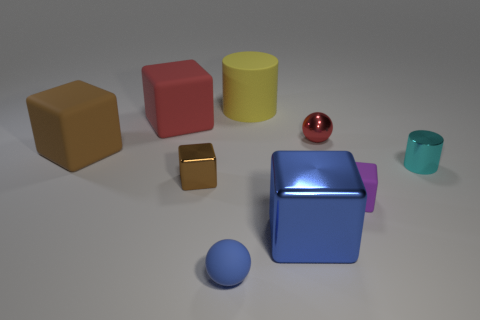Subtract 2 cubes. How many cubes are left? 3 Subtract all purple blocks. How many blocks are left? 4 Subtract all blue blocks. How many blocks are left? 4 Subtract all yellow blocks. Subtract all cyan spheres. How many blocks are left? 5 Subtract all spheres. How many objects are left? 7 Add 9 small brown rubber blocks. How many small brown rubber blocks exist? 9 Subtract 0 purple cylinders. How many objects are left? 9 Subtract all small blue rubber objects. Subtract all big cylinders. How many objects are left? 7 Add 4 yellow matte cylinders. How many yellow matte cylinders are left? 5 